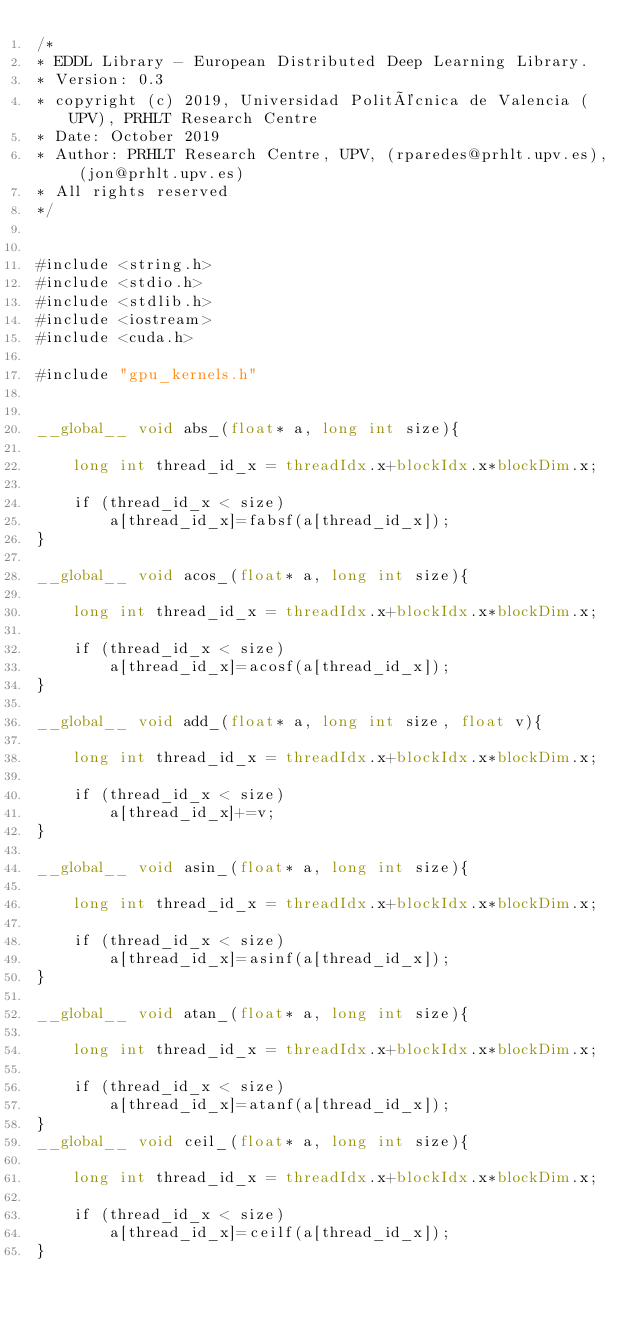<code> <loc_0><loc_0><loc_500><loc_500><_Cuda_>/*
* EDDL Library - European Distributed Deep Learning Library.
* Version: 0.3
* copyright (c) 2019, Universidad Politécnica de Valencia (UPV), PRHLT Research Centre
* Date: October 2019
* Author: PRHLT Research Centre, UPV, (rparedes@prhlt.upv.es), (jon@prhlt.upv.es)
* All rights reserved
*/


#include <string.h>
#include <stdio.h>
#include <stdlib.h>
#include <iostream>
#include <cuda.h>

#include "gpu_kernels.h"


__global__ void abs_(float* a, long int size){

    long int thread_id_x = threadIdx.x+blockIdx.x*blockDim.x;

    if (thread_id_x < size)
        a[thread_id_x]=fabsf(a[thread_id_x]);
}

__global__ void acos_(float* a, long int size){

    long int thread_id_x = threadIdx.x+blockIdx.x*blockDim.x;

    if (thread_id_x < size)
        a[thread_id_x]=acosf(a[thread_id_x]);
}

__global__ void add_(float* a, long int size, float v){

    long int thread_id_x = threadIdx.x+blockIdx.x*blockDim.x;

    if (thread_id_x < size)
        a[thread_id_x]+=v;
}

__global__ void asin_(float* a, long int size){

    long int thread_id_x = threadIdx.x+blockIdx.x*blockDim.x;

    if (thread_id_x < size)
        a[thread_id_x]=asinf(a[thread_id_x]);
}

__global__ void atan_(float* a, long int size){

    long int thread_id_x = threadIdx.x+blockIdx.x*blockDim.x;

    if (thread_id_x < size)
        a[thread_id_x]=atanf(a[thread_id_x]);
}
__global__ void ceil_(float* a, long int size){

    long int thread_id_x = threadIdx.x+blockIdx.x*blockDim.x;

    if (thread_id_x < size)
        a[thread_id_x]=ceilf(a[thread_id_x]);
}
</code> 